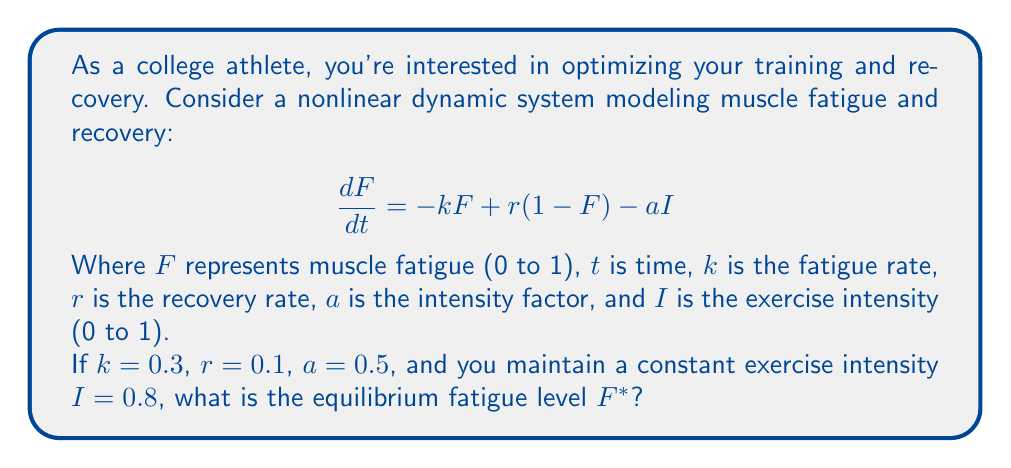Solve this math problem. To find the equilibrium fatigue level $F^*$, we need to set $\frac{dF}{dt} = 0$ and solve for $F$. This gives us:

1) Set the equation to zero:
   $$0 = -kF^* + r(1-F^*) - aI$$

2) Substitute the given values:
   $$0 = -0.3F^* + 0.1(1-F^*) - 0.5(0.8)$$

3) Simplify:
   $$0 = -0.3F^* + 0.1 - 0.1F^* - 0.4$$
   $$0 = -0.4F^* - 0.3$$

4) Solve for $F^*$:
   $$0.4F^* = -0.3$$
   $$F^* = -0.3 / 0.4 = -0.75$$

5) However, since fatigue is measured from 0 to 1, we need to ensure our answer is within this range. The negative value indicates that the equilibrium point is outside the valid range, so the fatigue will approach the maximum value of 1.

Therefore, the equilibrium fatigue level $F^*$ is 1, representing complete fatigue under these conditions.
Answer: $F^* = 1$ 